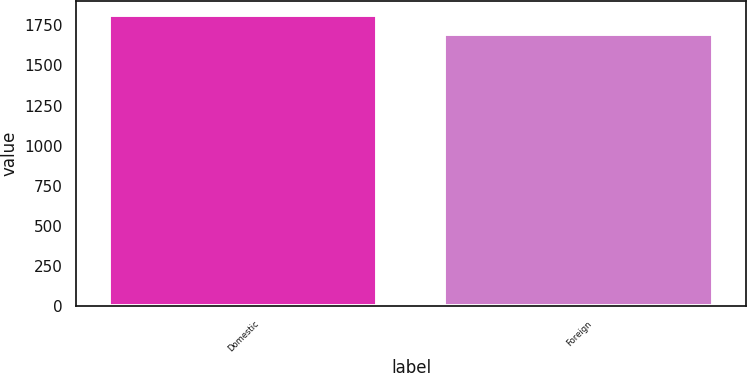Convert chart to OTSL. <chart><loc_0><loc_0><loc_500><loc_500><bar_chart><fcel>Domestic<fcel>Foreign<nl><fcel>1812<fcel>1693<nl></chart> 